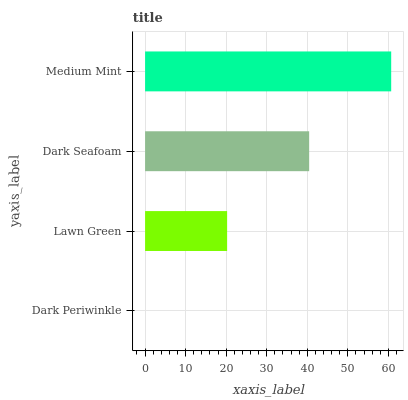Is Dark Periwinkle the minimum?
Answer yes or no. Yes. Is Medium Mint the maximum?
Answer yes or no. Yes. Is Lawn Green the minimum?
Answer yes or no. No. Is Lawn Green the maximum?
Answer yes or no. No. Is Lawn Green greater than Dark Periwinkle?
Answer yes or no. Yes. Is Dark Periwinkle less than Lawn Green?
Answer yes or no. Yes. Is Dark Periwinkle greater than Lawn Green?
Answer yes or no. No. Is Lawn Green less than Dark Periwinkle?
Answer yes or no. No. Is Dark Seafoam the high median?
Answer yes or no. Yes. Is Lawn Green the low median?
Answer yes or no. Yes. Is Lawn Green the high median?
Answer yes or no. No. Is Medium Mint the low median?
Answer yes or no. No. 